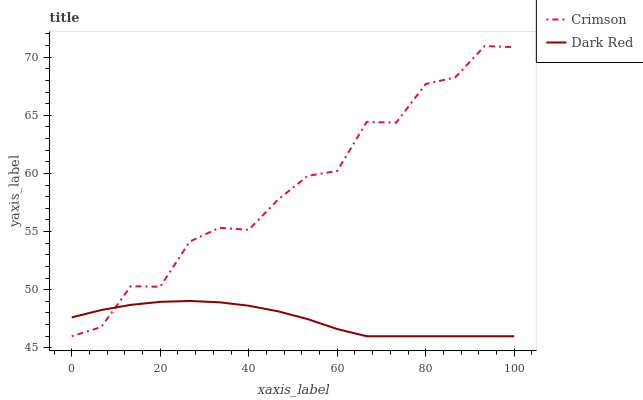Does Dark Red have the minimum area under the curve?
Answer yes or no. Yes. Does Crimson have the maximum area under the curve?
Answer yes or no. Yes. Does Dark Red have the maximum area under the curve?
Answer yes or no. No. Is Dark Red the smoothest?
Answer yes or no. Yes. Is Crimson the roughest?
Answer yes or no. Yes. Is Dark Red the roughest?
Answer yes or no. No. Does Crimson have the lowest value?
Answer yes or no. Yes. Does Crimson have the highest value?
Answer yes or no. Yes. Does Dark Red have the highest value?
Answer yes or no. No. Does Crimson intersect Dark Red?
Answer yes or no. Yes. Is Crimson less than Dark Red?
Answer yes or no. No. Is Crimson greater than Dark Red?
Answer yes or no. No. 